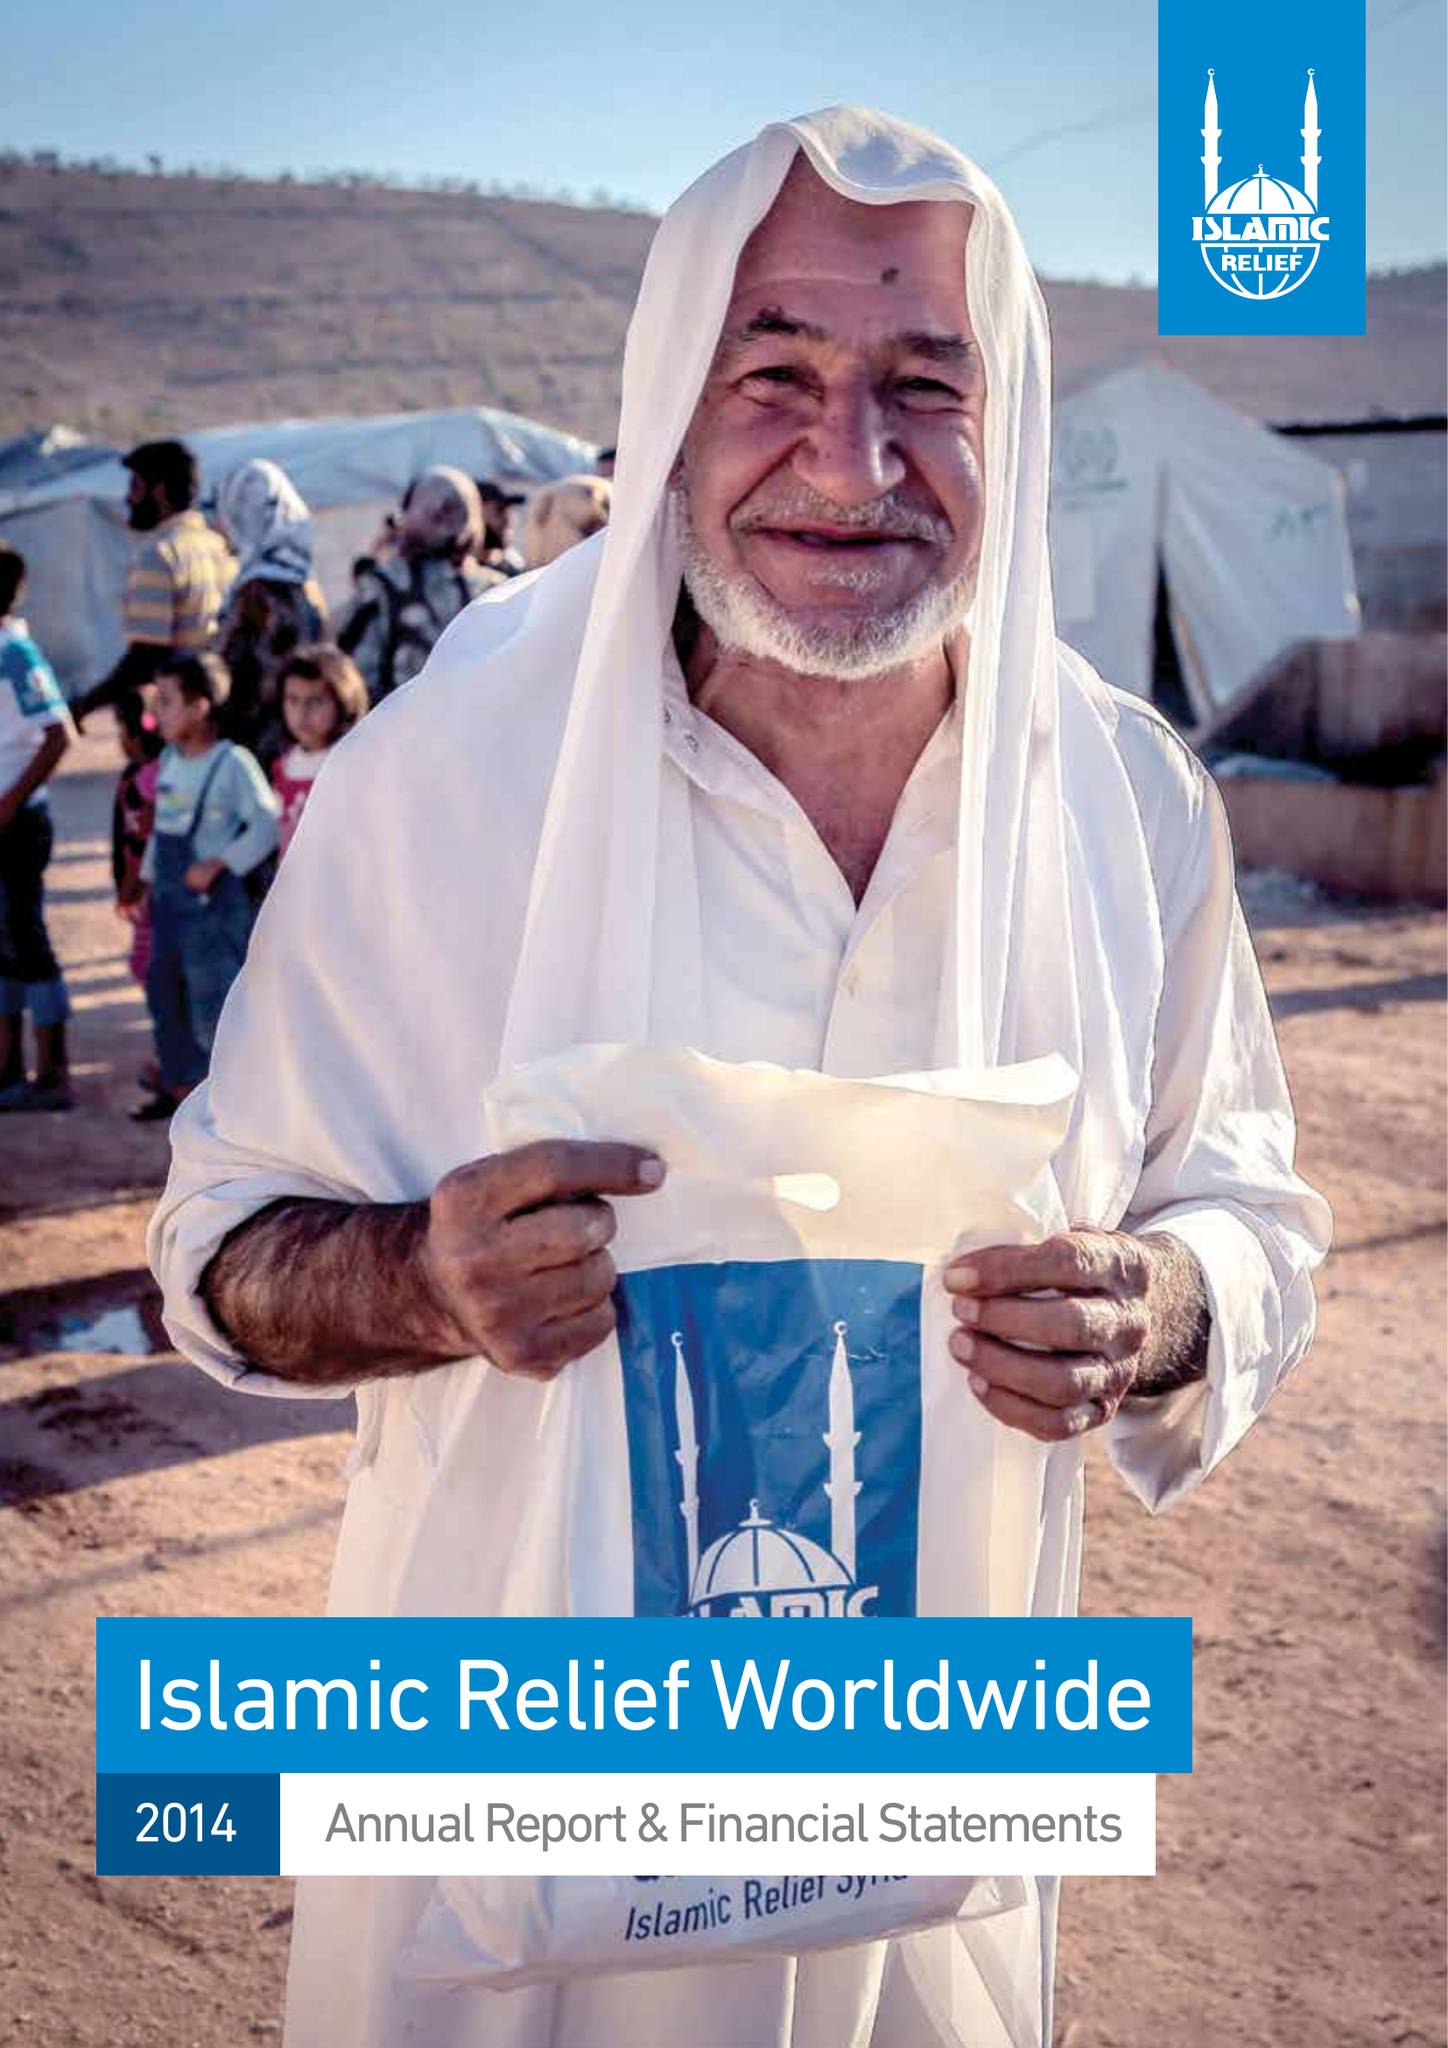What is the value for the spending_annually_in_british_pounds?
Answer the question using a single word or phrase. 92387946.00 